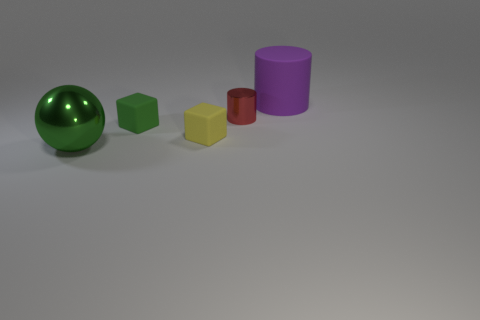Is the number of small yellow cubes greater than the number of small gray shiny objects?
Keep it short and to the point. Yes. Are the yellow thing and the large green sphere made of the same material?
Your answer should be very brief. No. What number of small green objects have the same material as the large purple cylinder?
Keep it short and to the point. 1. There is a green block; is its size the same as the purple rubber cylinder on the right side of the yellow matte block?
Offer a terse response. No. There is a object that is right of the yellow matte cube and on the left side of the rubber cylinder; what color is it?
Provide a short and direct response. Red. There is a tiny matte cube in front of the green cube; is there a big sphere behind it?
Keep it short and to the point. No. Is the number of large matte objects to the left of the tiny green cube the same as the number of cylinders?
Provide a succinct answer. No. How many green metal spheres are left of the shiny object right of the green thing behind the tiny yellow rubber object?
Offer a terse response. 1. Are there any other purple rubber cylinders that have the same size as the rubber cylinder?
Ensure brevity in your answer.  No. Are there fewer small rubber cubes that are to the left of the tiny green object than tiny purple spheres?
Give a very brief answer. No. 